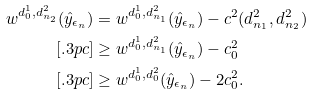Convert formula to latex. <formula><loc_0><loc_0><loc_500><loc_500>w ^ { d _ { 0 } ^ { 1 } , d _ { n _ { 2 } } ^ { 2 } } ( \hat { y } _ { \epsilon _ { n } } ) & = w ^ { d _ { 0 } ^ { 1 } , d _ { n _ { 1 } } ^ { 2 } } ( \hat { y } _ { \epsilon _ { n } } ) - c ^ { 2 } ( d _ { n _ { 1 } } ^ { 2 } , d _ { n _ { 2 } } ^ { 2 } ) \\ [ . 3 p c ] & \geq w ^ { d _ { 0 } ^ { 1 } , d _ { n _ { 1 } } ^ { 2 } } ( \hat { y } _ { \epsilon _ { n } } ) - c ^ { 2 } _ { 0 } \\ [ . 3 p c ] & \geq w ^ { d _ { 0 } ^ { 1 } , d _ { 0 } ^ { 2 } } ( \hat { y } _ { \epsilon _ { n } } ) - 2 c ^ { 2 } _ { 0 } .</formula> 